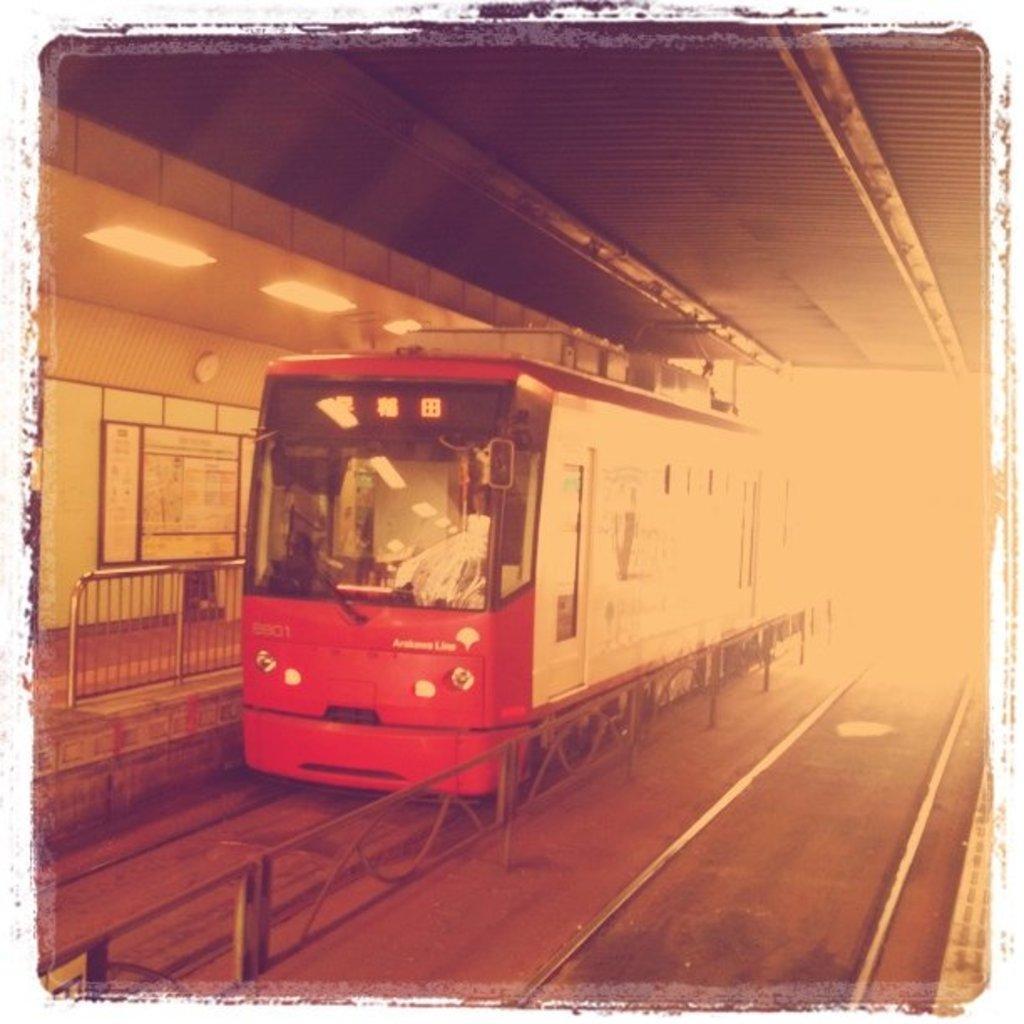Describe this image in one or two sentences. In this image I can see the railing, few railway tracks and a train which is red in color on the track. I can see the platform, the wall, a board attached to the wall, the ceiling and few lights to the ceiling. 